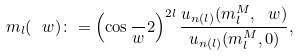<formula> <loc_0><loc_0><loc_500><loc_500>m _ { l } ( \ w ) \colon = \left ( \cos \frac { \ } { w } 2 \right ) ^ { 2 l } \frac { u _ { n ( l ) } ( m ^ { M } _ { l } , \ w ) } { u _ { n ( l ) } ( m ^ { M } _ { l } , 0 ) } ,</formula> 